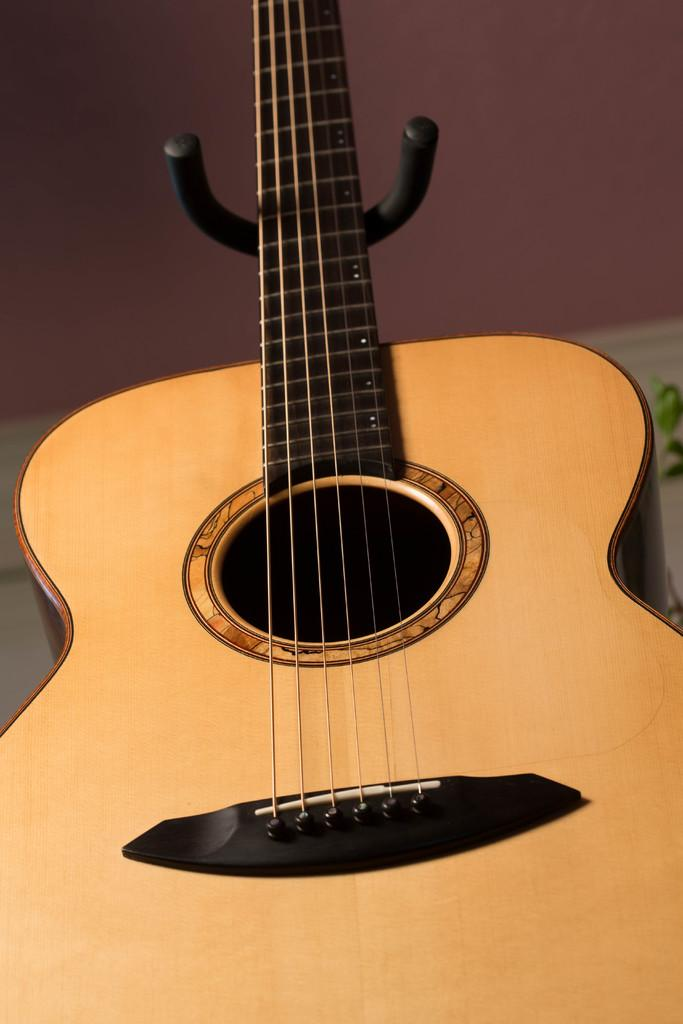What musical instrument is present in the image? There is a guitar in the image. What is the color of the guitar? The guitar is brown in color. Where is the guitar located in the image? The guitar is on a table. What type of sail can be seen on the guitar in the image? There is no sail present on the guitar in the image; it is a musical instrument, not a sailboat. 